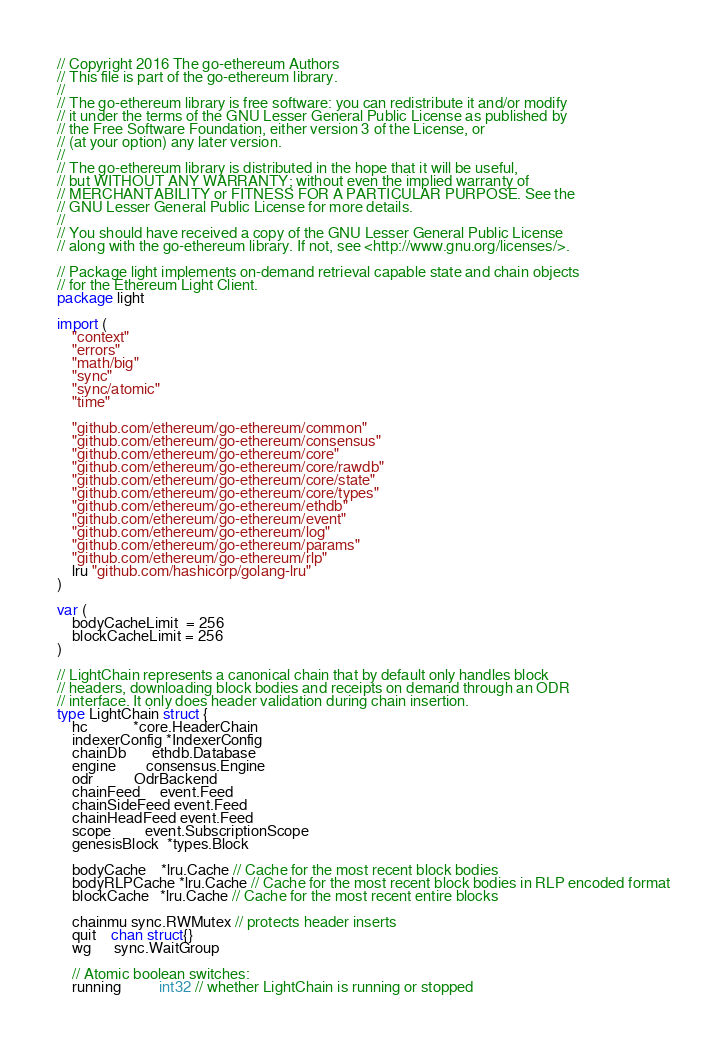<code> <loc_0><loc_0><loc_500><loc_500><_Go_>// Copyright 2016 The go-ethereum Authors
// This file is part of the go-ethereum library.
//
// The go-ethereum library is free software: you can redistribute it and/or modify
// it under the terms of the GNU Lesser General Public License as published by
// the Free Software Foundation, either version 3 of the License, or
// (at your option) any later version.
//
// The go-ethereum library is distributed in the hope that it will be useful,
// but WITHOUT ANY WARRANTY; without even the implied warranty of
// MERCHANTABILITY or FITNESS FOR A PARTICULAR PURPOSE. See the
// GNU Lesser General Public License for more details.
//
// You should have received a copy of the GNU Lesser General Public License
// along with the go-ethereum library. If not, see <http://www.gnu.org/licenses/>.

// Package light implements on-demand retrieval capable state and chain objects
// for the Ethereum Light Client.
package light

import (
	"context"
	"errors"
	"math/big"
	"sync"
	"sync/atomic"
	"time"

	"github.com/ethereum/go-ethereum/common"
	"github.com/ethereum/go-ethereum/consensus"
	"github.com/ethereum/go-ethereum/core"
	"github.com/ethereum/go-ethereum/core/rawdb"
	"github.com/ethereum/go-ethereum/core/state"
	"github.com/ethereum/go-ethereum/core/types"
	"github.com/ethereum/go-ethereum/ethdb"
	"github.com/ethereum/go-ethereum/event"
	"github.com/ethereum/go-ethereum/log"
	"github.com/ethereum/go-ethereum/params"
	"github.com/ethereum/go-ethereum/rlp"
	lru "github.com/hashicorp/golang-lru"
)

var (
	bodyCacheLimit  = 256
	blockCacheLimit = 256
)

// LightChain represents a canonical chain that by default only handles block
// headers, downloading block bodies and receipts on demand through an ODR
// interface. It only does header validation during chain insertion.
type LightChain struct {
	hc            *core.HeaderChain
	indexerConfig *IndexerConfig
	chainDb       ethdb.Database
	engine        consensus.Engine
	odr           OdrBackend
	chainFeed     event.Feed
	chainSideFeed event.Feed
	chainHeadFeed event.Feed
	scope         event.SubscriptionScope
	genesisBlock  *types.Block

	bodyCache    *lru.Cache // Cache for the most recent block bodies
	bodyRLPCache *lru.Cache // Cache for the most recent block bodies in RLP encoded format
	blockCache   *lru.Cache // Cache for the most recent entire blocks

	chainmu sync.RWMutex // protects header inserts
	quit    chan struct{}
	wg      sync.WaitGroup

	// Atomic boolean switches:
	running          int32 // whether LightChain is running or stopped</code> 